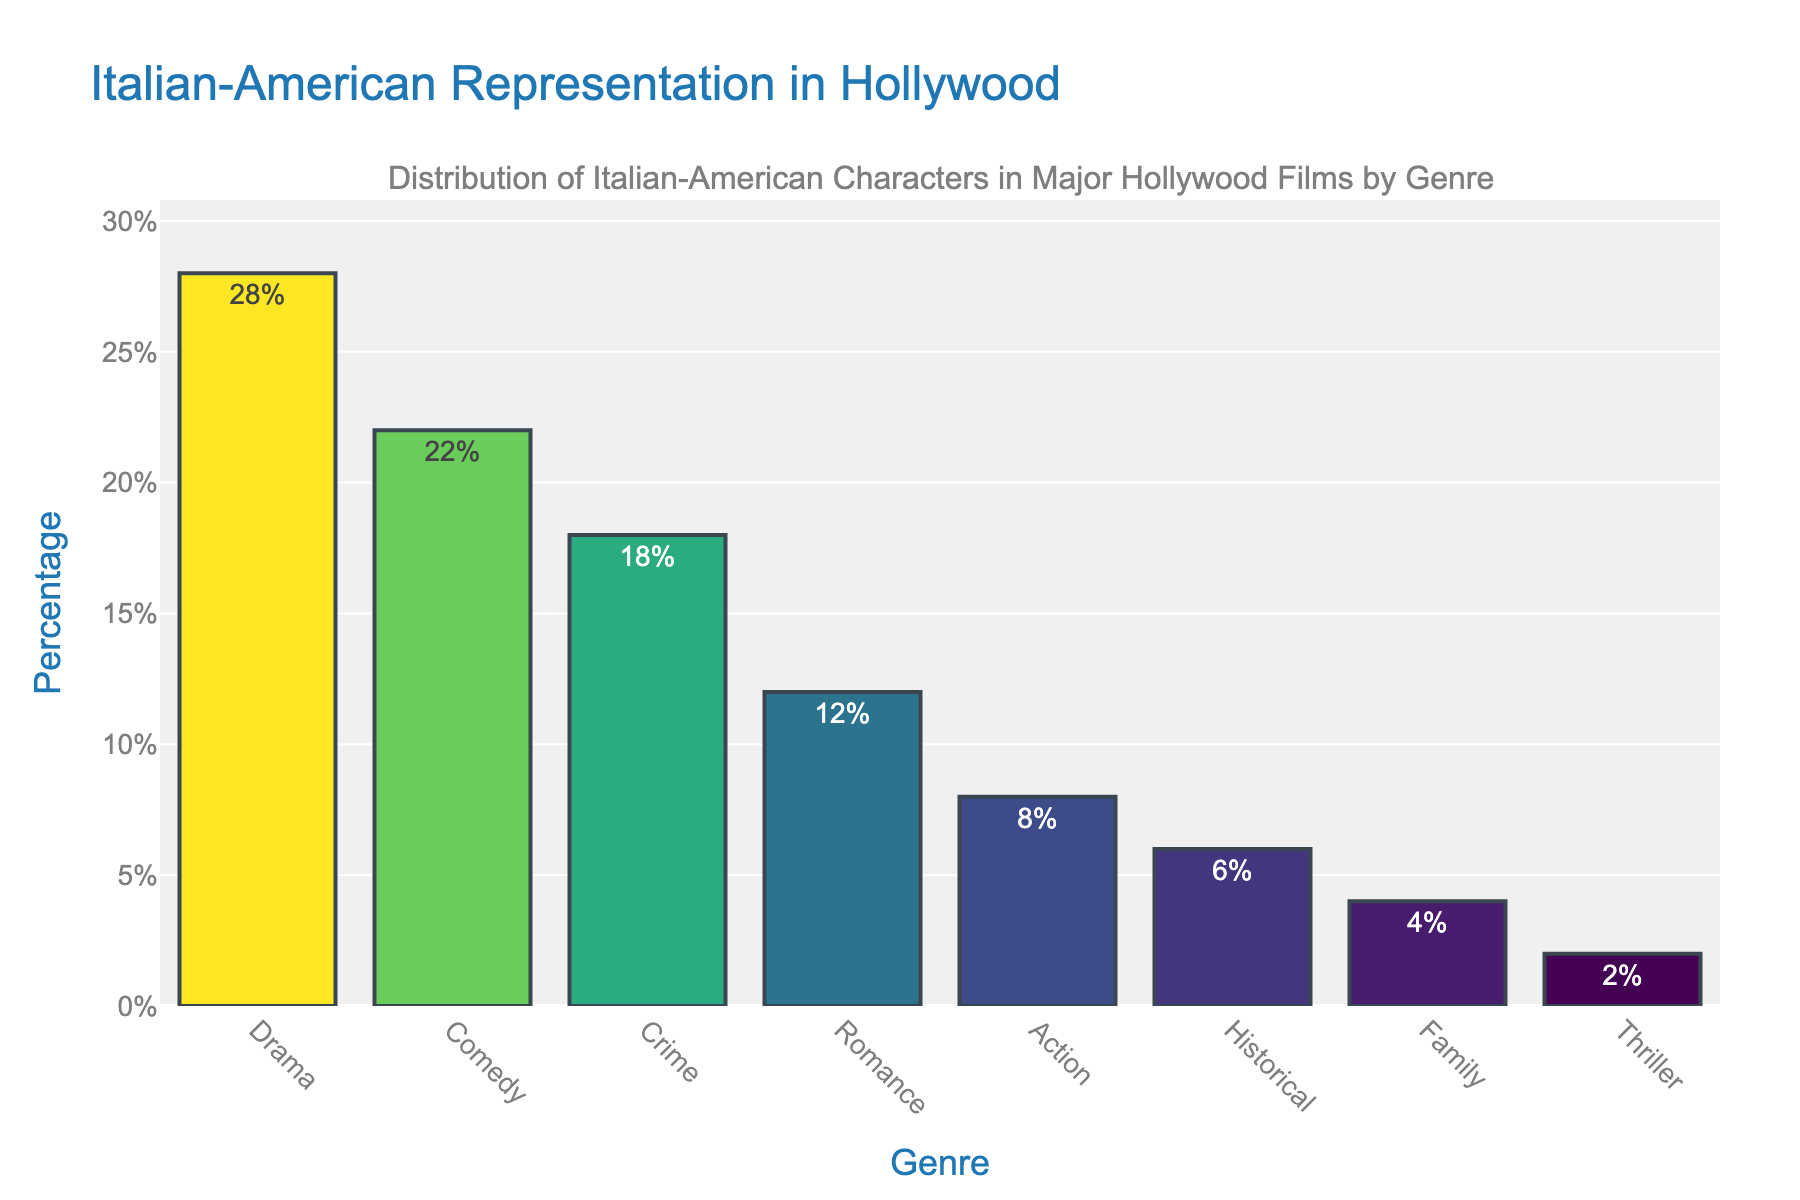What genre has the highest percentage of Italian-American characters? The Drama genre has the tallest bar, indicating it has the highest percentage.
Answer: Drama Which genres have a higher percentage than Comedy? The genres with higher percentages than Comedy are Drama, as its bar is taller.
Answer: Drama How much higher is the percentage of Italian-American characters in Drama compared to Crime? The bar for Drama represents 28%, and the bar for Crime represents 18%. The difference is 28% - 18% = 10%.
Answer: 10% What is the total percentage of Italian-American characters in Drama and Comedy combined? The percentages for Drama and Comedy are 28% and 22%, respectively. Summing these gives 28% + 22% = 50%.
Answer: 50% Is the percentage of Italian-American characters in Romance and Action combined greater than in Crime? The combined percentage for Romance and Action is 12% + 8% = 20%. This is greater than the 18% for Crime.
Answer: Yes Which genre has almost the same percentage as Family? The Thriller genre has a very similar percentage to Family, as the bars for both genres are nearly equal in height.
Answer: Thriller Are there more Italian-American characters in Historical or Family films? The Historical genre has a taller bar than the Family genre, indicating a higher percentage of Italian-American characters.
Answer: Historical What percentage of Italian-American characters are in genres other than Drama and Comedy? The total percentage in Drama and Comedy is 28% + 22% = 50%. Therefore, the percentage in other genres is 100% - 50% = 50%.
Answer: 50% Rank the genres from highest to lowest percentage of Italian-American characters. The percentages in descending order are Drama (28%), Comedy (22%), Crime (18%), Romance (12%), Action (8%), Historical (6%), Family (4%), and Thriller (2%).
Answer: Drama, Comedy, Crime, Romance, Action, Historical, Family, Thriller Which genre has the lowest percentage of Italian-American characters? The Thriller genre has the shortest bar, indicating it has the lowest percentage.
Answer: Thriller 